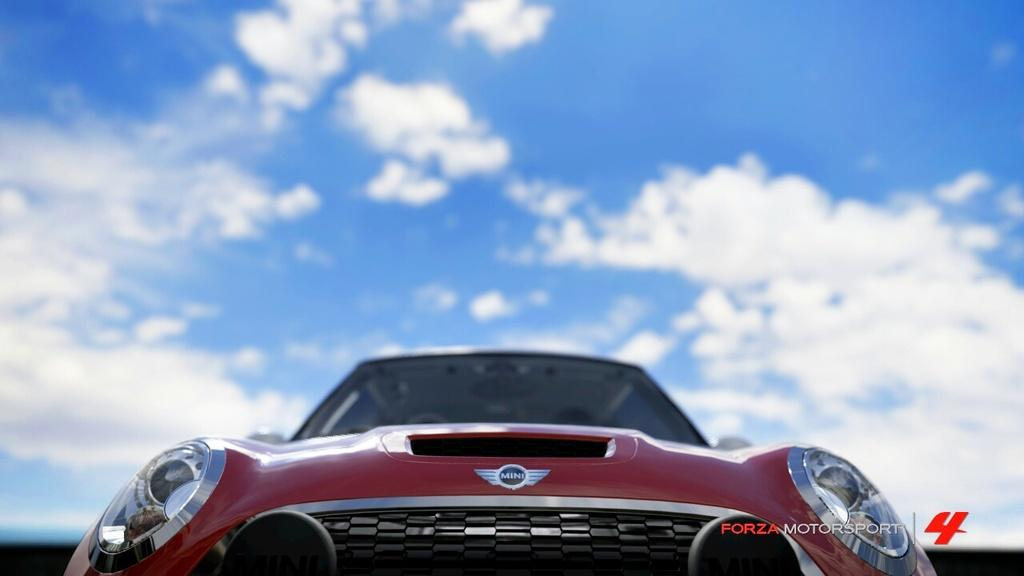What is the main subject of the image? There is a vehicle in the image. Where is the vehicle located in the image? The vehicle is at the bottom of the image. What else can be seen at the bottom of the image? There is text at the bottom of the image. What is visible at the top of the image? The sky is visible at the top of the image. What type of art is displayed on the vehicle in the image? There is no art displayed on the vehicle in the image; it is not mentioned in the provided facts. Is there any wine being served in the image? There is no mention of wine or any beverages in the image. Can you see a horse in the image? There is no horse present in the image. 